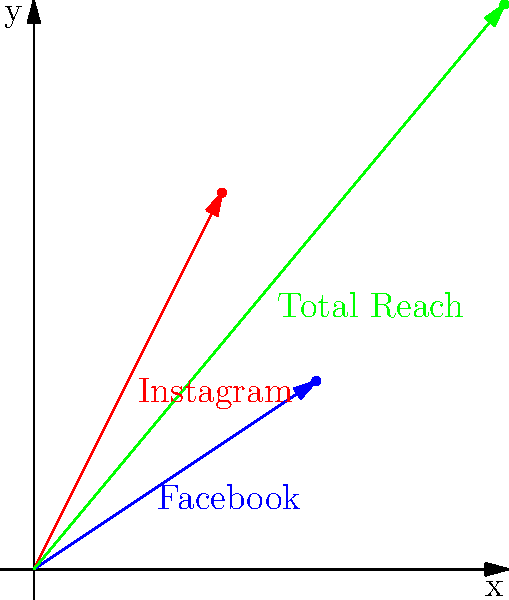As a social media marketing manager, you've launched a campaign across Facebook and Instagram. The reach vector for Facebook is $\vec{a} = (3, 2)$ million users, and for Instagram is $\vec{b} = (2, 4)$ million users. Calculate the total reach vector and its magnitude (in millions of users) using vector addition. To solve this problem, we'll follow these steps:

1) First, we need to add the two vectors $\vec{a}$ and $\vec{b}$ to get the total reach vector $\vec{c}$:

   $\vec{c} = \vec{a} + \vec{b} = (3, 2) + (2, 4)$

2) To add vectors, we add their corresponding components:

   $\vec{c} = (3+2, 2+4) = (5, 6)$

3) Now that we have the total reach vector $\vec{c} = (5, 6)$, we need to calculate its magnitude. The magnitude of a vector $(x, y)$ is given by the formula $\sqrt{x^2 + y^2}$.

4) Let's substitute our values:

   $|\vec{c}| = \sqrt{5^2 + 6^2} = \sqrt{25 + 36} = \sqrt{61}$

5) Simplify:

   $|\vec{c}| = \sqrt{61} \approx 7.81$ million users

Therefore, the total reach vector is $(5, 6)$ million users, and its magnitude (total reach) is approximately 7.81 million users.
Answer: Total reach vector: $(5, 6)$ million users; Magnitude: $\sqrt{61} \approx 7.81$ million users 